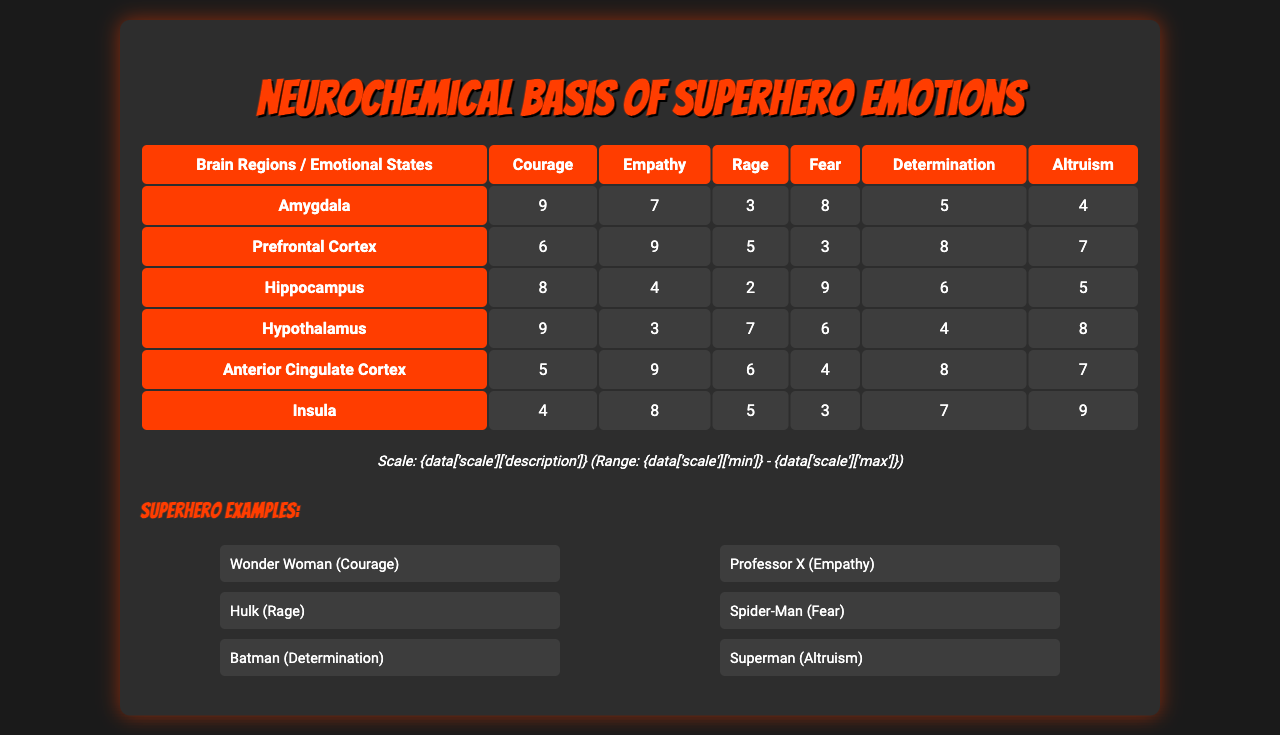What is the activation level for the Prefrontal Cortex when experiencing Determination? From the table, we look under the "Prefrontal Cortex" row and the "Determination" column, which has a value of 8.
Answer: 8 What is the highest activation level for the Amygdala across all emotional states? Checking the Amygdala row, the values are 9 (Courage), 7 (Empathy), 3 (Rage), 8 (Fear), 5 (Determination), and 4 (Altruism). The highest value is 9.
Answer: 9 Does the Insula have a higher activation level for Altruism than the Hippocampus? Looking at the Insula and Hippocampus rows for Altruism, Insula has a value of 9 and Hippocampus has a value of 5. Since 9 is greater than 5, the statement is true.
Answer: Yes What is the average activation level for the emotional state of Fear across all brain regions? To find the average for Fear, we sum the values (8 + 3 + 9 + 6 + 4 + 3) = 33, and there are 6 values, so the average is 33 / 6 = 5.5.
Answer: 5.5 Which emotional state has the lowest total activation level across all brain regions? Adding the columns for each emotional state: Courage (9 + 6 + 8 + 9 + 5 + 4 = 41), Empathy (7 + 9 + 4 + 3 + 9 + 8 = 40), Rage (3 + 5 + 2 + 7 + 6 + 5 = 28), Fear (8 + 3 + 9 + 6 + 4 + 3 = 33), Determination (5 + 8 + 6 + 4 + 8 + 7 = 38), Altruism (4 + 7 + 5 + 8 + 7 + 9 = 40). Rage has the lowest total of 28.
Answer: Rage Which brain region is most associated with the emotional state of Courage? The activation level for Courage in different brain regions shows that the Amygdala has the highest activation level at 9, making it the most associated with Courage.
Answer: Amygdala What is the total activation level of the Hypothalamus when experiencing Fear and Rage? The values for Hypothalamus in Fear and Rage are 6 and 7, respectively. Adding these values gives 6 + 7 = 13 for a total activation level.
Answer: 13 Which brain region shows a notable increase in activation when experiencing Empathy compared to Rage? For Empathy, the Prefrontal Cortex shows a value of 9, while for Rage, it shows a value of 5. The difference is 9 - 5 = 4, indicating an increase.
Answer: Yes What are the emotional states with a total activation level higher than 35? Calculating totals: Courage = 41, Empathy = 40, Rage = 28, Fear = 33, Determination = 38, Altruism = 40. The emotional states that exceed 35 are Courage, Empathy, Determination, and Altruism.
Answer: Courage, Empathy, Determination, Altruism Is Altruism the emotional state with the highest activation in the Insula? In the Insula row, the activation values are 4 (Courage), 7 (Empathy), 5 (Rage), 3 (Fear), 7 (Determination), and 9 (Altruism). Since 9 is the highest, it means Altruism has that distinction.
Answer: Yes 